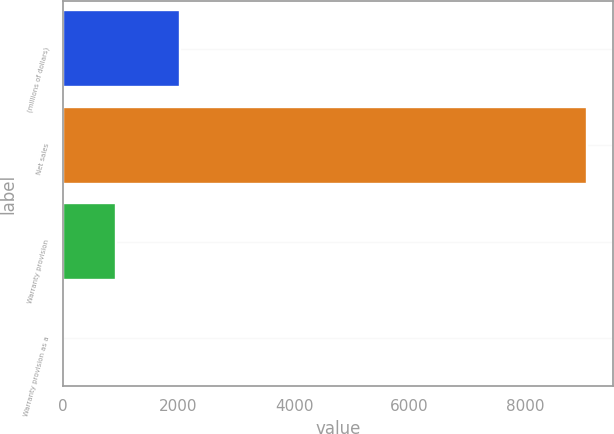<chart> <loc_0><loc_0><loc_500><loc_500><bar_chart><fcel>(millions of dollars)<fcel>Net sales<fcel>Warranty provision<fcel>Warranty provision as a<nl><fcel>2016<fcel>9071<fcel>907.73<fcel>0.7<nl></chart> 